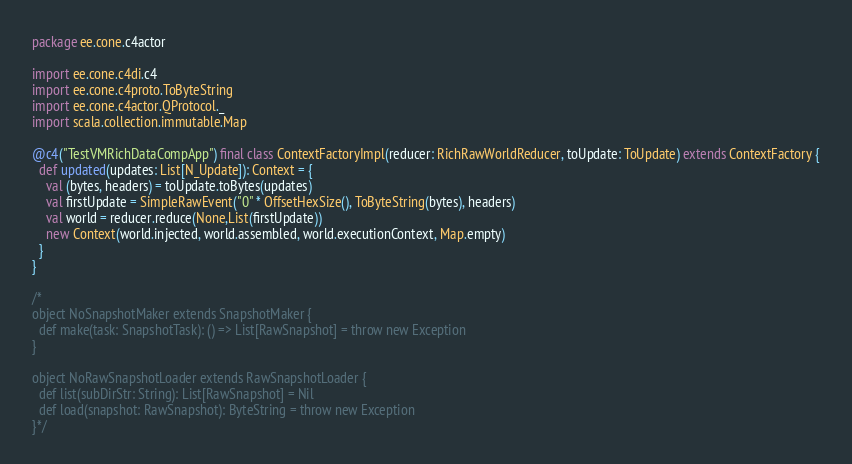<code> <loc_0><loc_0><loc_500><loc_500><_Scala_>package ee.cone.c4actor

import ee.cone.c4di.c4
import ee.cone.c4proto.ToByteString
import ee.cone.c4actor.QProtocol._
import scala.collection.immutable.Map

@c4("TestVMRichDataCompApp") final class ContextFactoryImpl(reducer: RichRawWorldReducer, toUpdate: ToUpdate) extends ContextFactory {
  def updated(updates: List[N_Update]): Context = {
    val (bytes, headers) = toUpdate.toBytes(updates)
    val firstUpdate = SimpleRawEvent("0" * OffsetHexSize(), ToByteString(bytes), headers)
    val world = reducer.reduce(None,List(firstUpdate))
    new Context(world.injected, world.assembled, world.executionContext, Map.empty)
  }
}

/*
object NoSnapshotMaker extends SnapshotMaker {
  def make(task: SnapshotTask): () => List[RawSnapshot] = throw new Exception
}

object NoRawSnapshotLoader extends RawSnapshotLoader {
  def list(subDirStr: String): List[RawSnapshot] = Nil
  def load(snapshot: RawSnapshot): ByteString = throw new Exception
}*/
</code> 